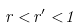Convert formula to latex. <formula><loc_0><loc_0><loc_500><loc_500>r < r ^ { \prime } < 1</formula> 